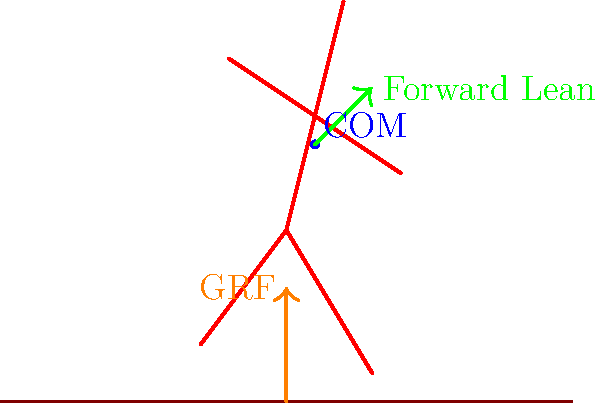In this stylized running pose for an action scene, what biomechanical principle is demonstrated by the forward lean of the body, and how does it contribute to the character's forward motion? To understand the biomechanics of this stylized running pose, let's break it down step-by-step:

1. Forward Lean: The figure is depicted with a forward lean, as shown by the green arrow in the diagram. This lean is crucial for running biomechanics.

2. Center of Mass (COM): The blue dot represents the character's center of mass, which is positioned forward of the support leg.

3. Ground Reaction Force (GRF): The orange arrow represents the ground reaction force, which is the force exerted by the ground on the runner's foot.

4. Principle of Momentum: The forward lean utilizes the principle of momentum. By leaning forward, the runner shifts their center of mass ahead of their base of support (feet).

5. Gravitational Force: This forward position of the COM creates a moment arm for gravity to act upon, essentially allowing the runner to "fall forward."

6. Propulsion: As the runner falls forward, they must move their legs to catch their body, resulting in forward motion.

7. Efficiency: This lean reduces the need for excessive muscular force to propel the body forward, making the running motion more efficient.

8. Balance with GRF: The forward lean is balanced by the ground reaction force, which prevents the runner from actually falling and allows for continuous forward motion.

The biomechanical principle demonstrated here is the manipulation of the body's center of mass to create controlled instability, which is then converted into forward motion. This principle is known as "gravitational torque" or "controlled falling."
Answer: Gravitational torque (controlled falling) 